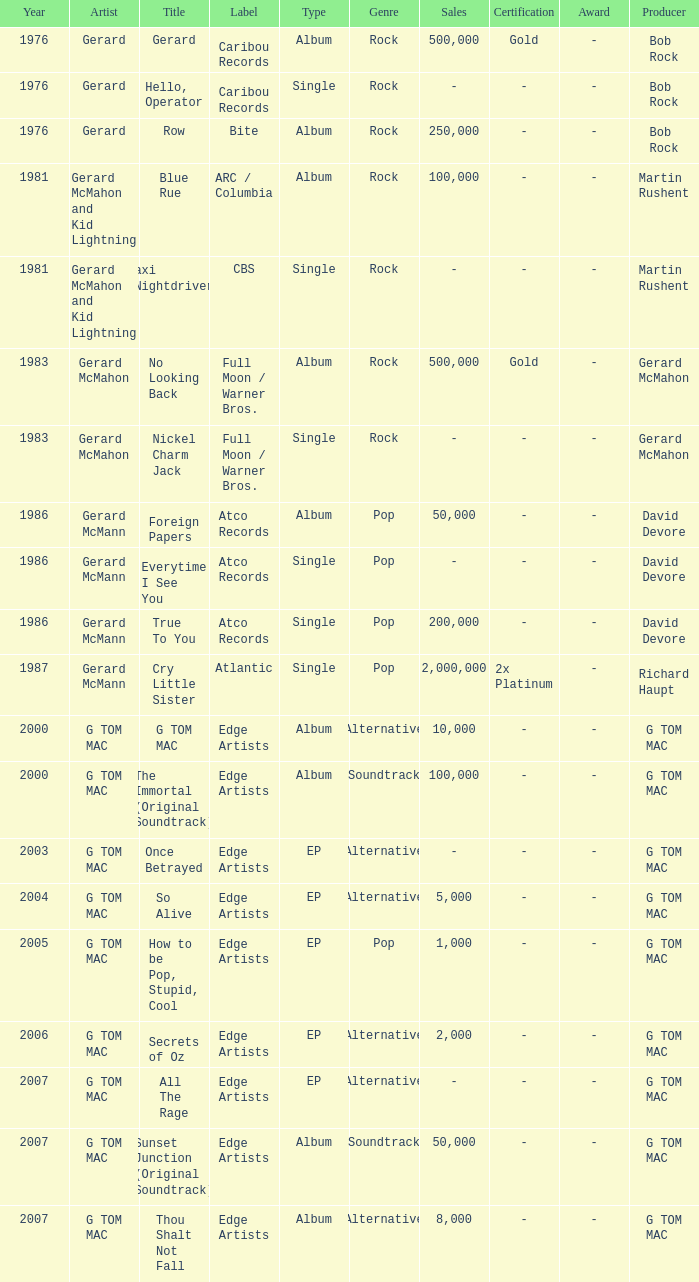Which type has a title of so alive? EP. 